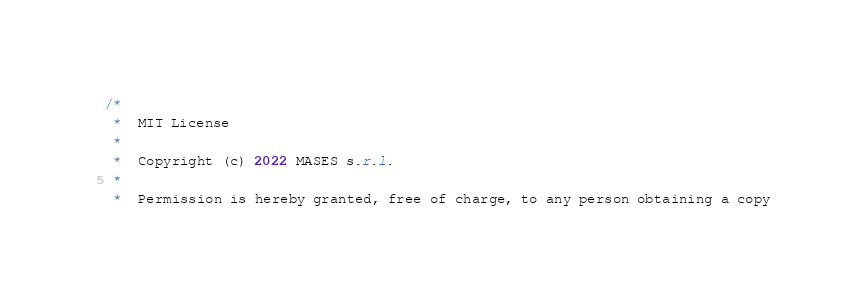Convert code to text. <code><loc_0><loc_0><loc_500><loc_500><_Java_>/*
 *  MIT License
 *
 *  Copyright (c) 2022 MASES s.r.l.
 *
 *  Permission is hereby granted, free of charge, to any person obtaining a copy</code> 